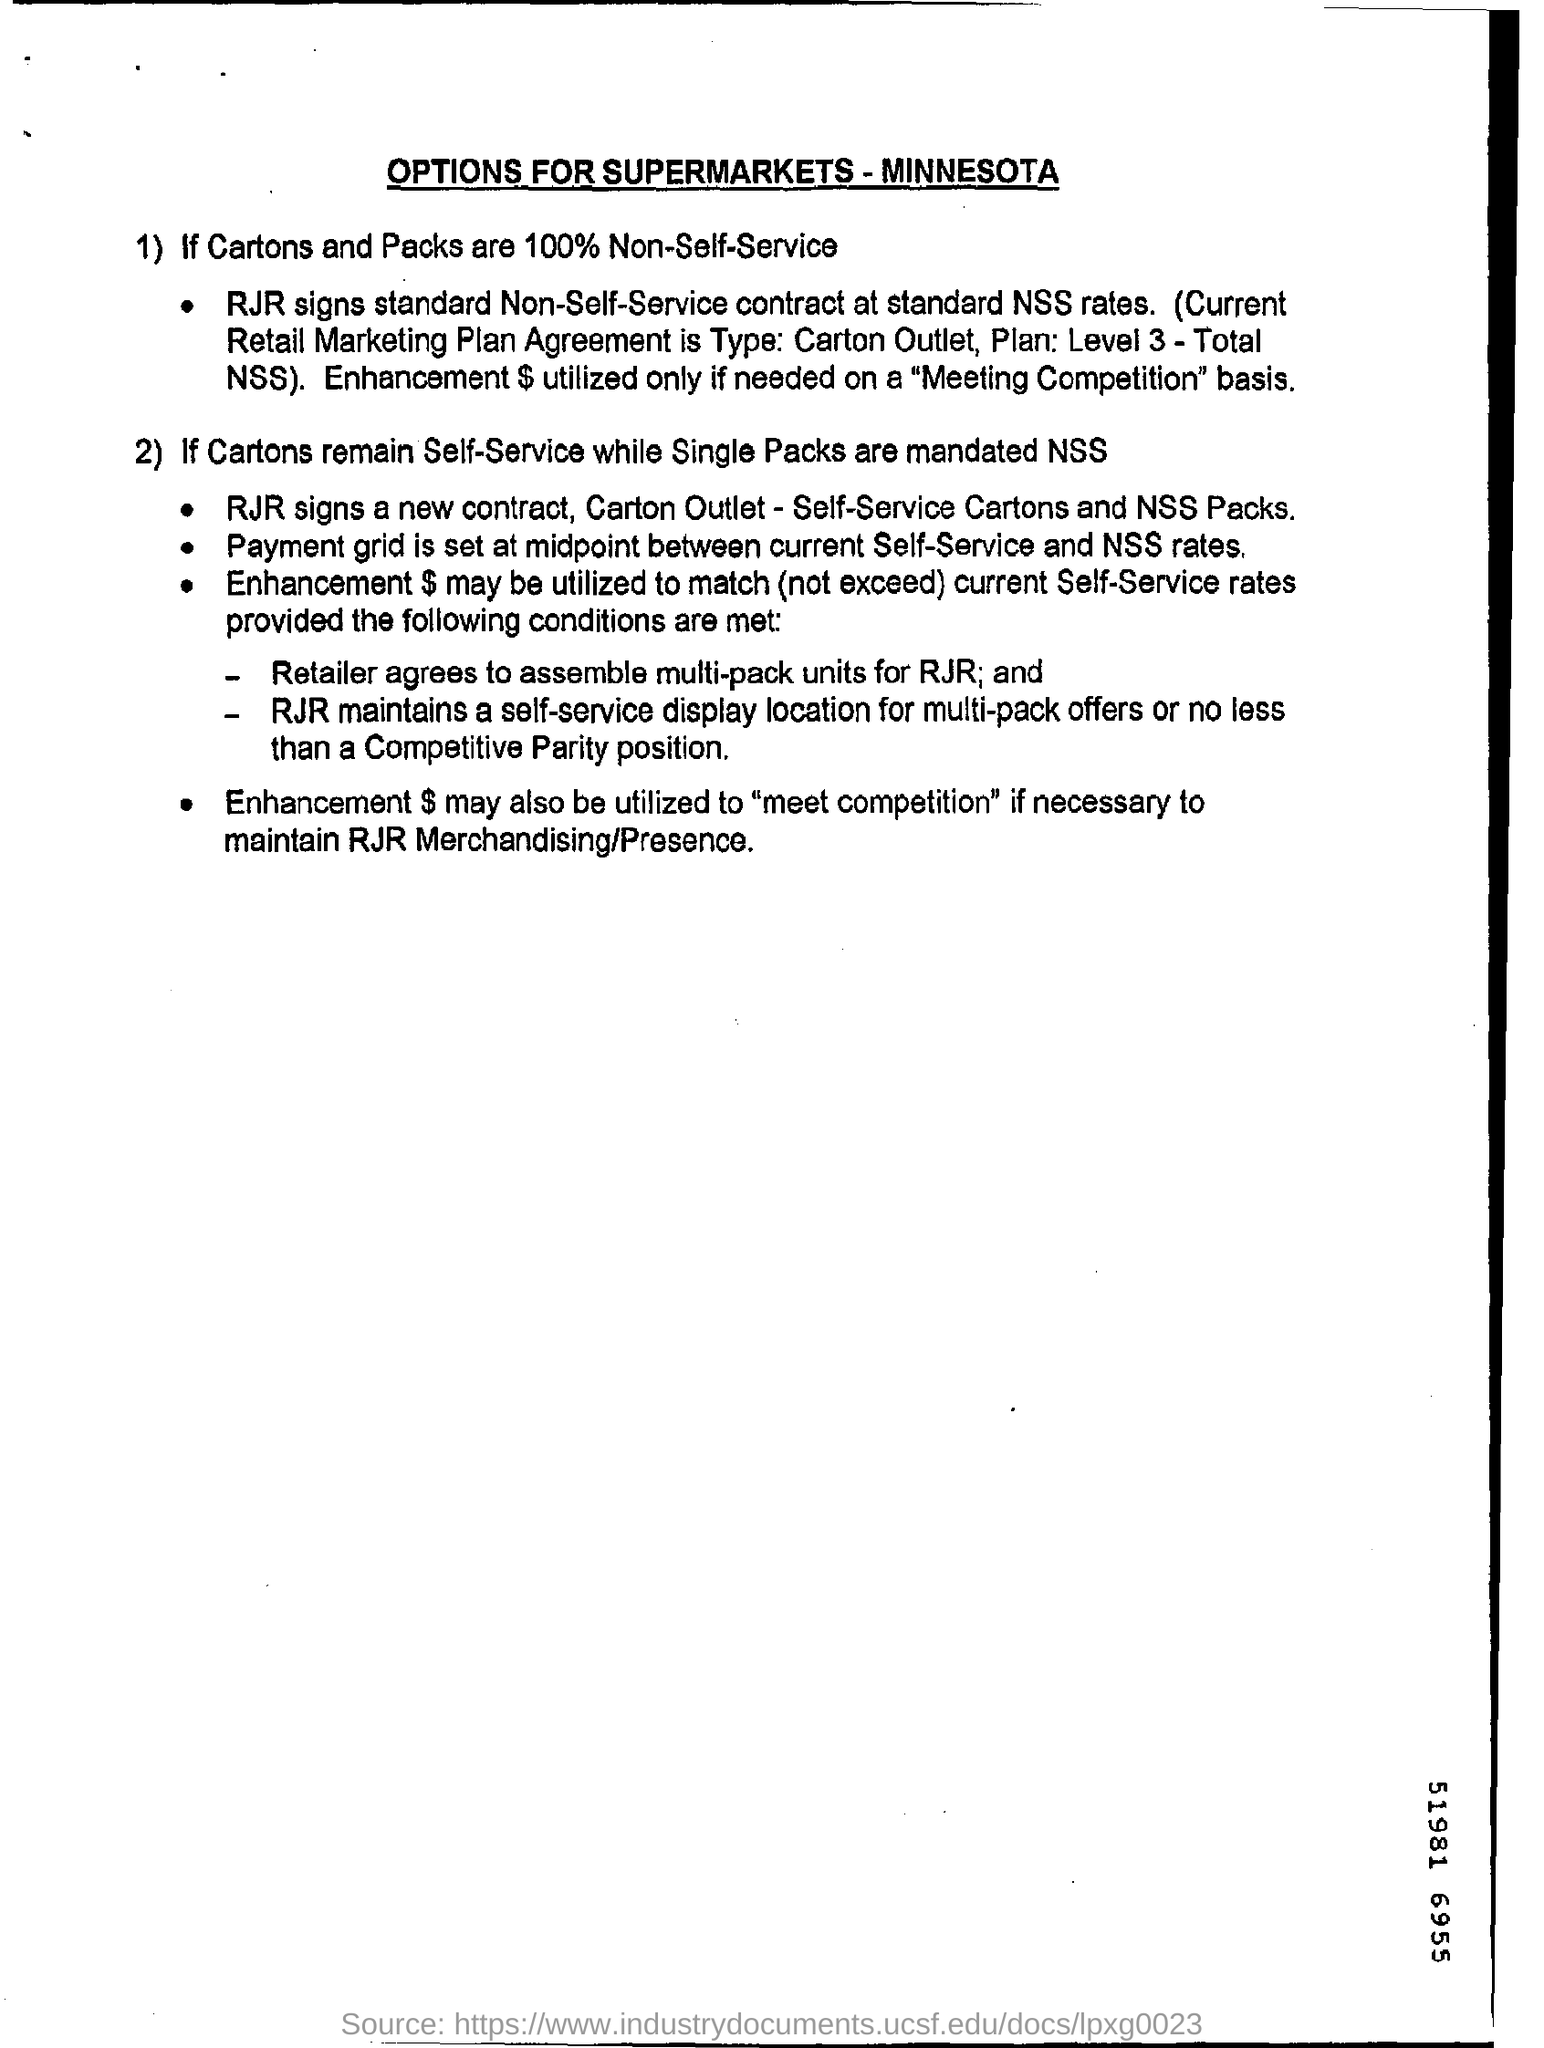What is the head line of this document?
Provide a short and direct response. Options for supermarkets - minnesota. What is the level of Plan?
Your answer should be very brief. 3. Who agrees to assemble multi pack units?
Ensure brevity in your answer.  Retailer. 